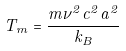Convert formula to latex. <formula><loc_0><loc_0><loc_500><loc_500>T _ { m } = \frac { m \nu ^ { 2 } c ^ { 2 } a ^ { 2 } } { k _ { B } }</formula> 